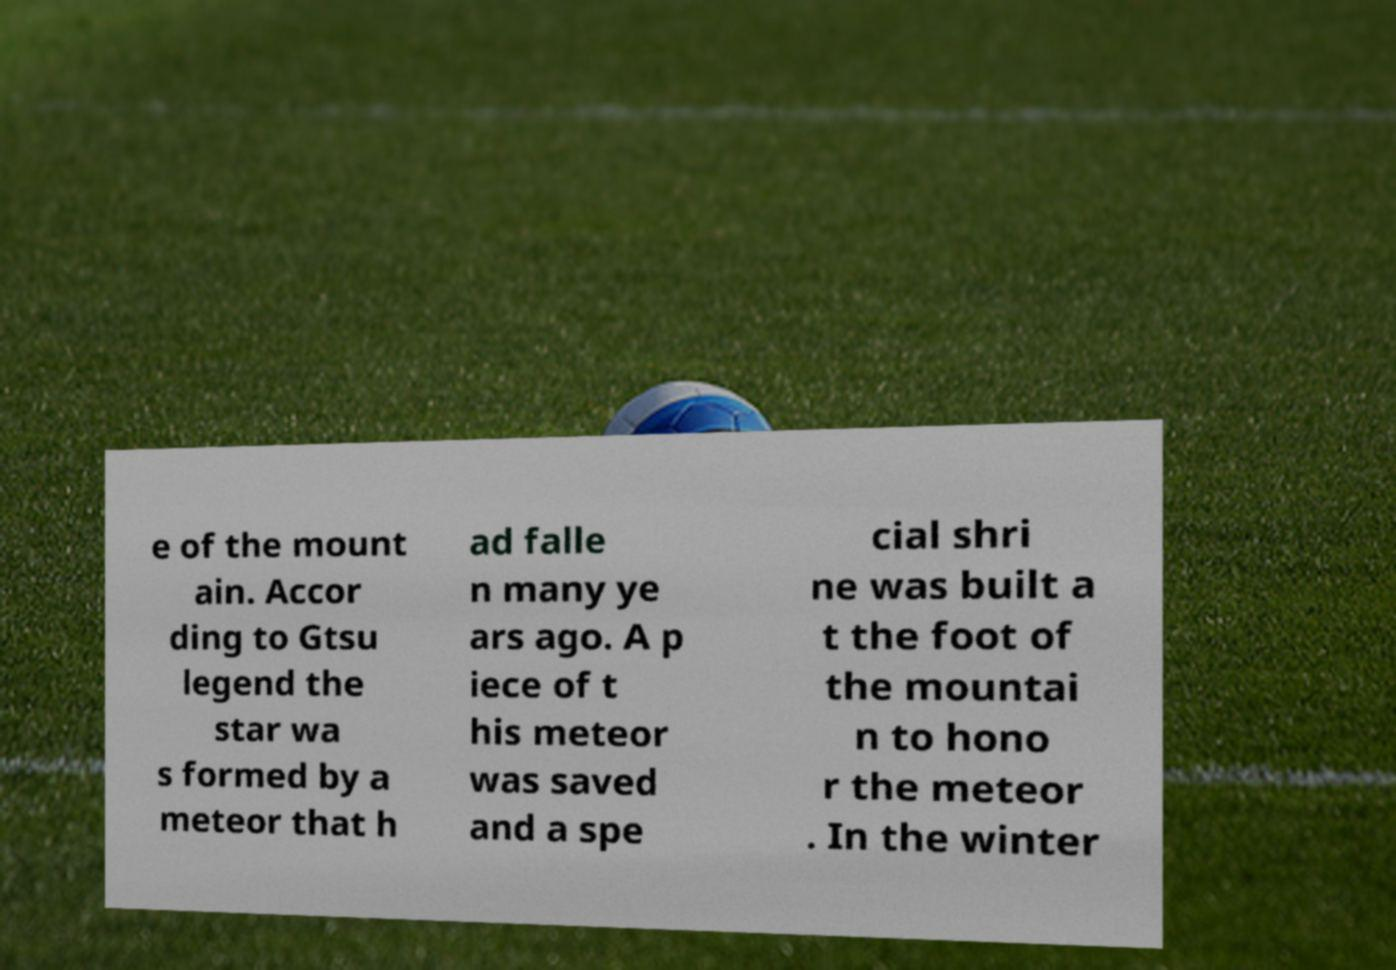For documentation purposes, I need the text within this image transcribed. Could you provide that? e of the mount ain. Accor ding to Gtsu legend the star wa s formed by a meteor that h ad falle n many ye ars ago. A p iece of t his meteor was saved and a spe cial shri ne was built a t the foot of the mountai n to hono r the meteor . In the winter 